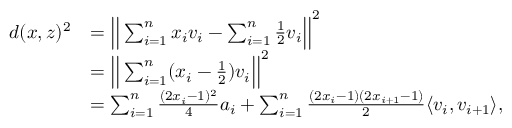Convert formula to latex. <formula><loc_0><loc_0><loc_500><loc_500>\begin{array} { r l } { d ( x , z ) ^ { 2 } } & { = \left | \right | \sum _ { i = 1 } ^ { n } x _ { i } v _ { i } - \sum _ { i = 1 } ^ { n } \frac { 1 } { 2 } v _ { i } \left | \right | ^ { 2 } } \\ & { = \left | \right | \sum _ { i = 1 } ^ { n } ( x _ { i } - \frac { 1 } { 2 } ) v _ { i } \left | \right | ^ { 2 } } \\ & { = \sum _ { i = 1 } ^ { n } \frac { ( 2 x _ { i } - 1 ) ^ { 2 } } { 4 } a _ { i } + \sum _ { i = 1 } ^ { n } \frac { ( 2 x _ { i } - 1 ) ( 2 x _ { i + 1 } - 1 ) } { 2 } \langle v _ { i } , v _ { i + 1 } \rangle , } \end{array}</formula> 